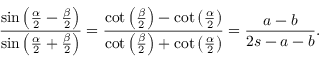<formula> <loc_0><loc_0><loc_500><loc_500>{ \frac { \sin \left ( { \frac { \alpha } { 2 } } - { \frac { \beta } { 2 } } \right ) } { \sin \left ( { \frac { \alpha } { 2 } } + { \frac { \beta } { 2 } } \right ) } } = { \frac { \cot \left ( { \frac { \beta } { 2 } } \right ) - \cot \left ( { \frac { \alpha } { 2 } } \right ) } { \cot \left ( { \frac { \beta } { 2 } } \right ) + \cot \left ( { \frac { \alpha } { 2 } } \right ) } } = { \frac { a - b } { 2 s - a - b } } .</formula> 